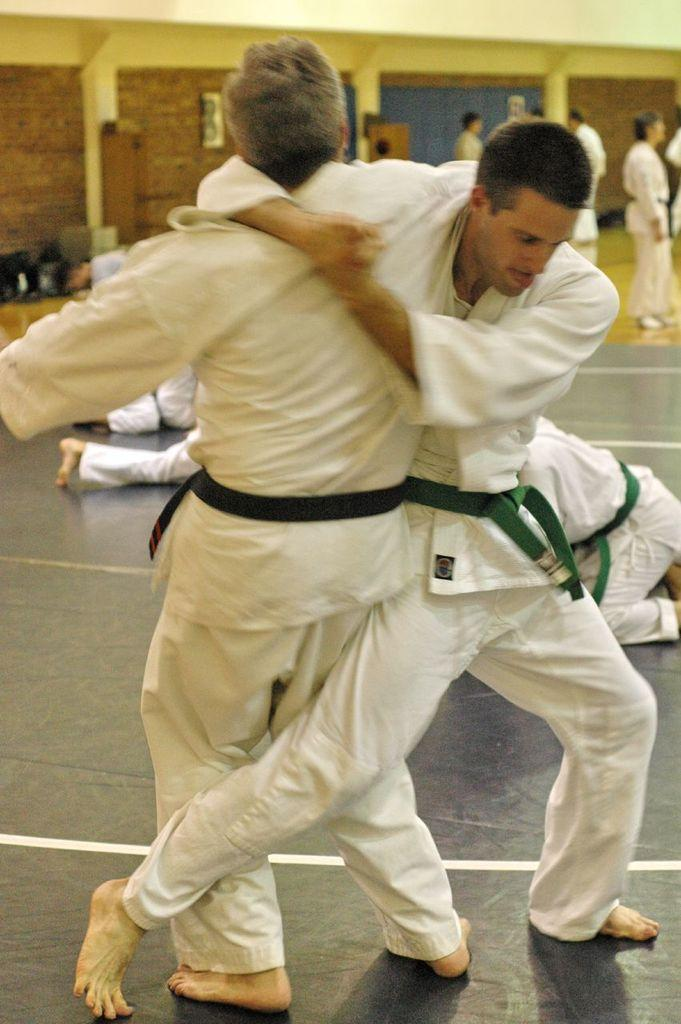How many people are in the image? There are people in the image, but the exact number is not specified. What are some of the people doing in the image? Some people are fighting in the image. What type of surface is visible in the image? There is ground visible in the image. What can be seen attached to the wall in the image? There is a wall with objects attached to it in the image. What type of coast can be seen in the image? There is no coast visible in the image. What type of legal advice is the lawyer providing in the image? There is no lawyer or legal advice present in the image. 